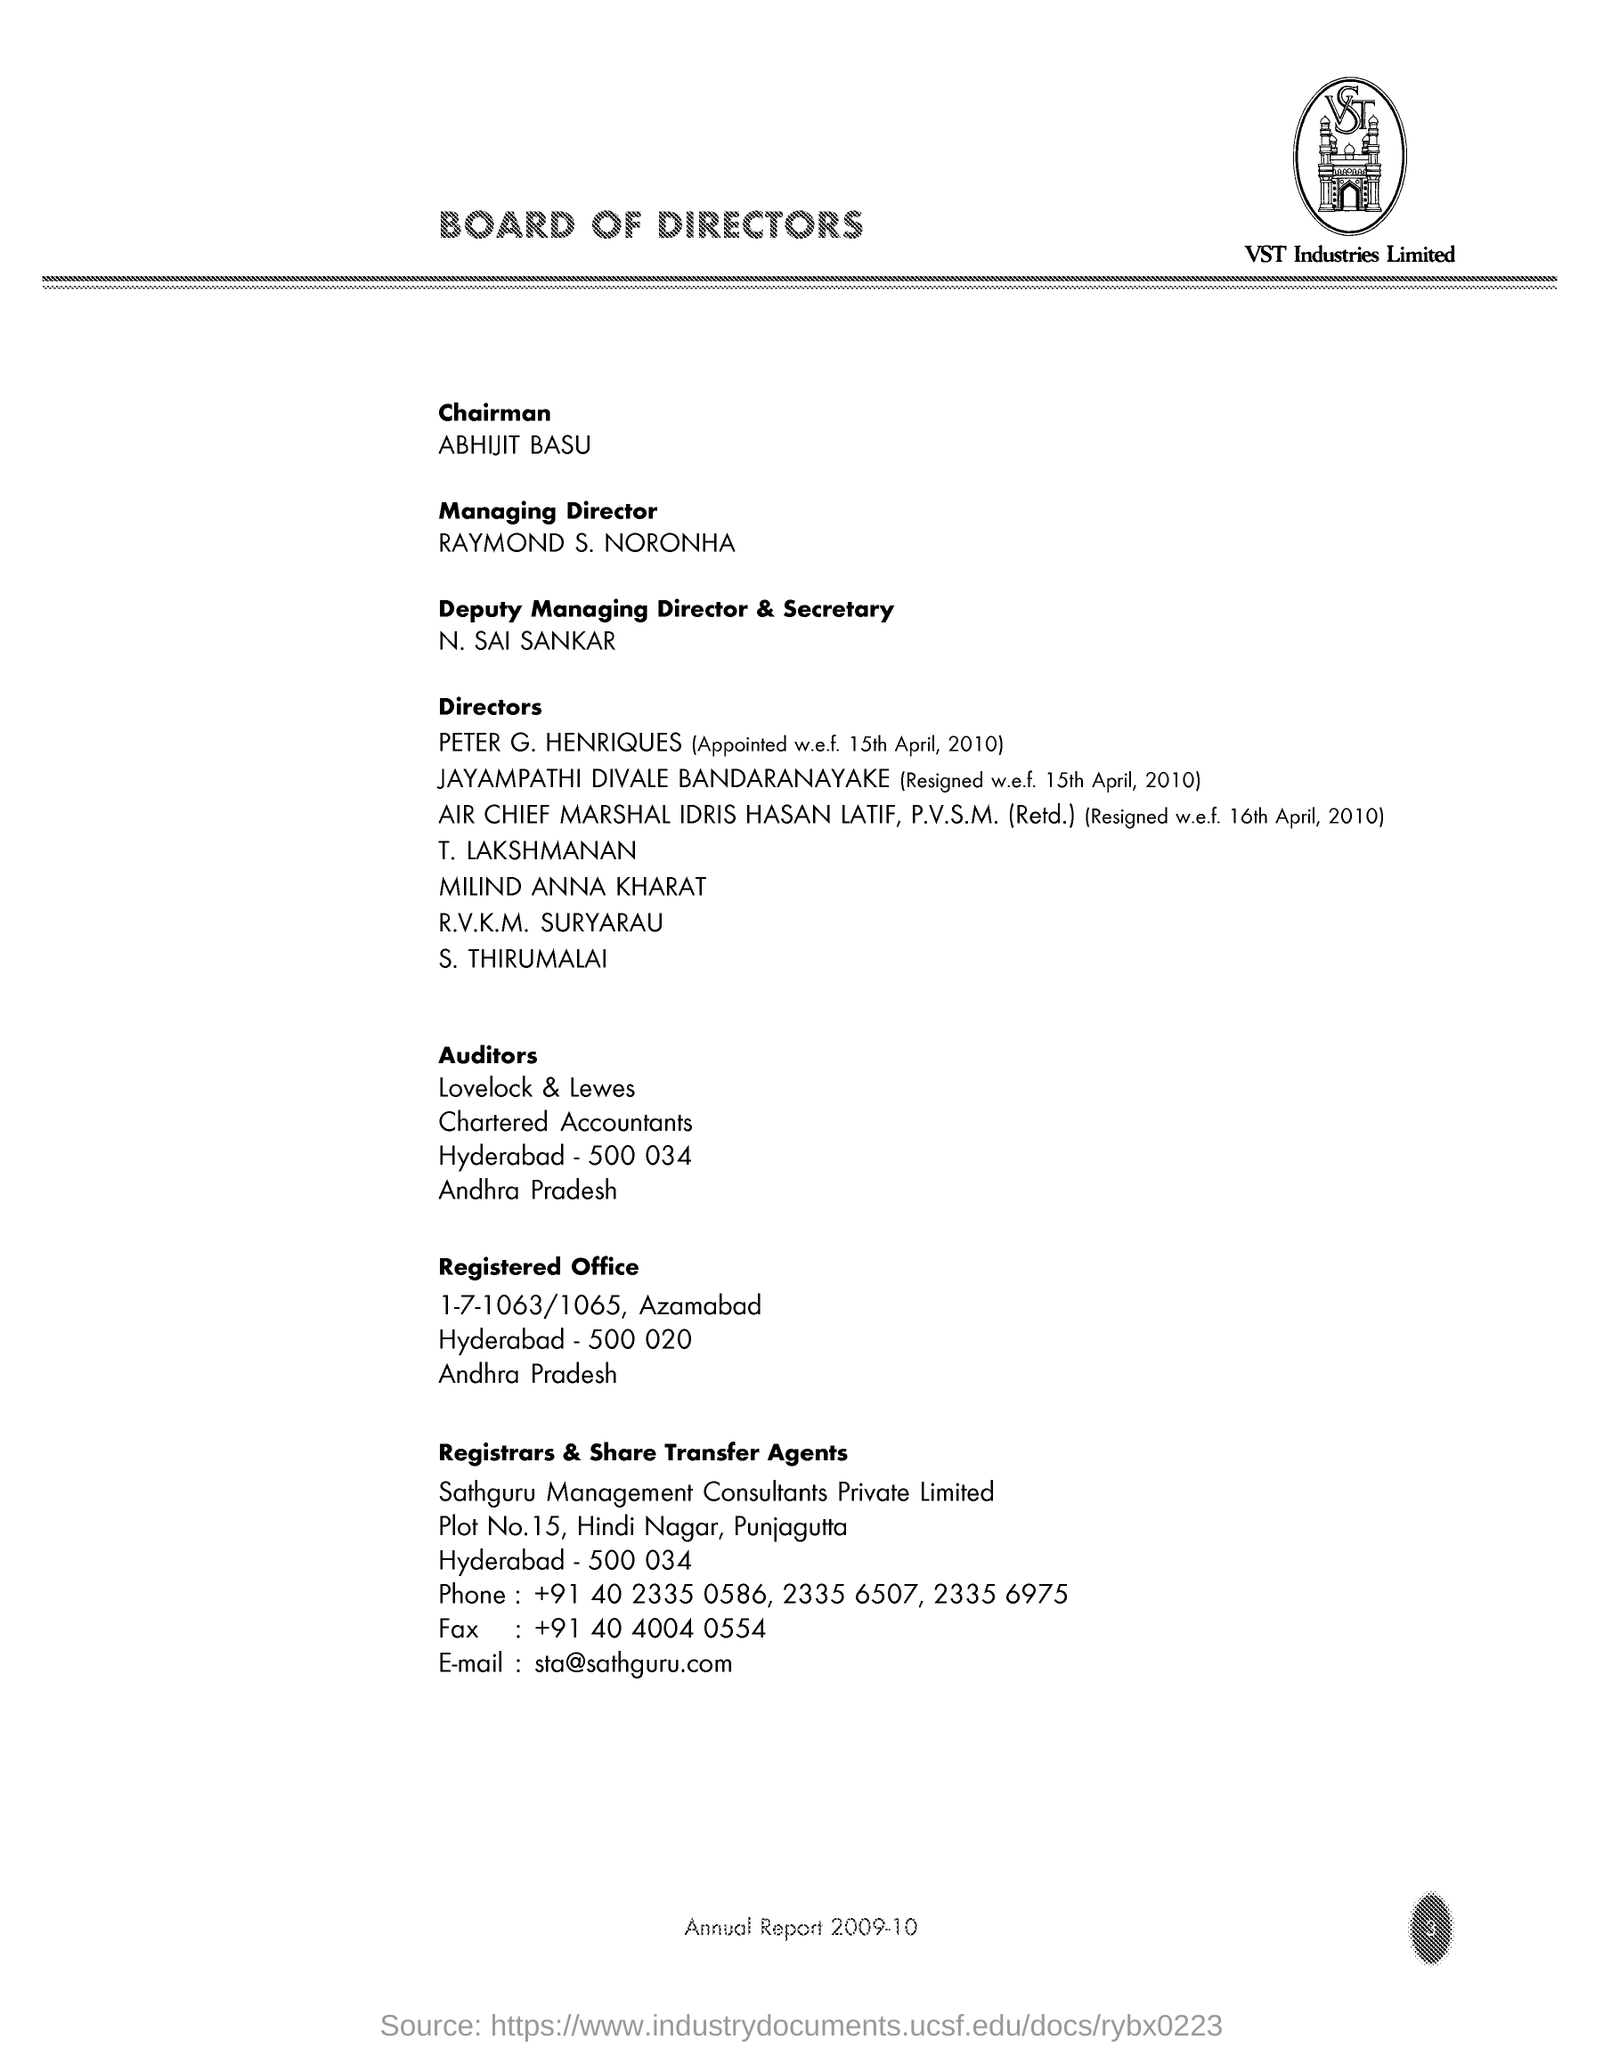Who is the Chairman ?
Offer a very short reply. ABHIJIT BASU. What is written in the Letter Head ?
Provide a short and direct response. BOARD OF DIRECTORS. What is the Company Name ?
Your answer should be compact. VST Industries Limited. What is the Fax Number ?
Offer a terse response. +91 40 4004 0554. Who is the Deputy Managing Director & Secretary ?
Ensure brevity in your answer.  N. SAI SANKAR. 